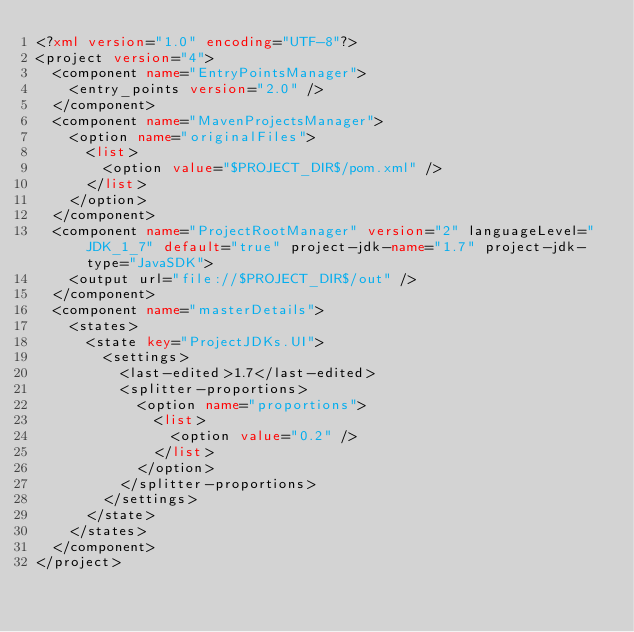<code> <loc_0><loc_0><loc_500><loc_500><_XML_><?xml version="1.0" encoding="UTF-8"?>
<project version="4">
  <component name="EntryPointsManager">
    <entry_points version="2.0" />
  </component>
  <component name="MavenProjectsManager">
    <option name="originalFiles">
      <list>
        <option value="$PROJECT_DIR$/pom.xml" />
      </list>
    </option>
  </component>
  <component name="ProjectRootManager" version="2" languageLevel="JDK_1_7" default="true" project-jdk-name="1.7" project-jdk-type="JavaSDK">
    <output url="file://$PROJECT_DIR$/out" />
  </component>
  <component name="masterDetails">
    <states>
      <state key="ProjectJDKs.UI">
        <settings>
          <last-edited>1.7</last-edited>
          <splitter-proportions>
            <option name="proportions">
              <list>
                <option value="0.2" />
              </list>
            </option>
          </splitter-proportions>
        </settings>
      </state>
    </states>
  </component>
</project></code> 